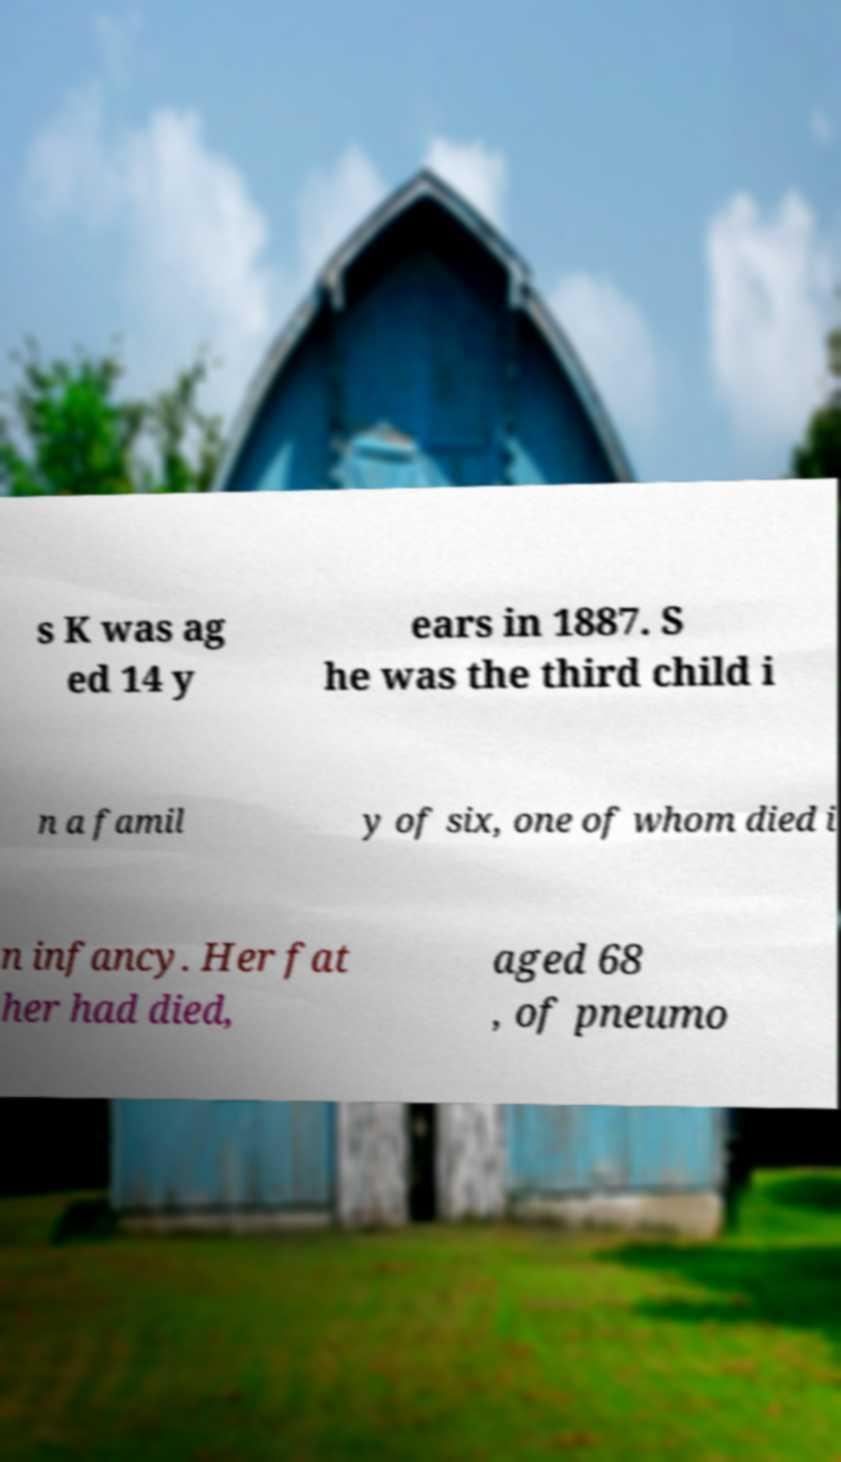Can you read and provide the text displayed in the image?This photo seems to have some interesting text. Can you extract and type it out for me? s K was ag ed 14 y ears in 1887. S he was the third child i n a famil y of six, one of whom died i n infancy. Her fat her had died, aged 68 , of pneumo 